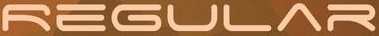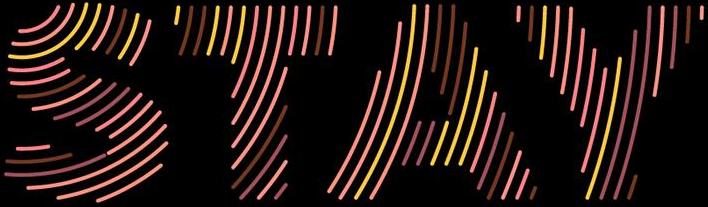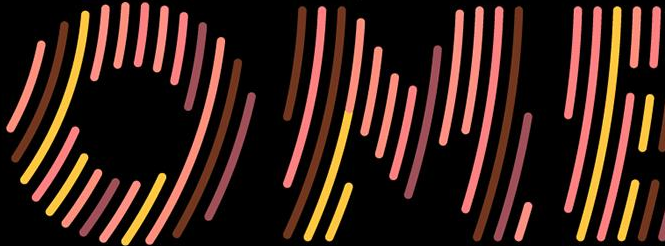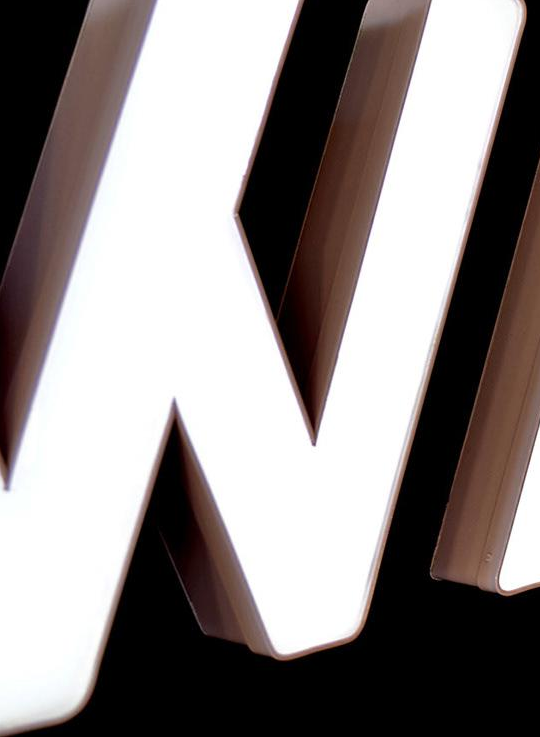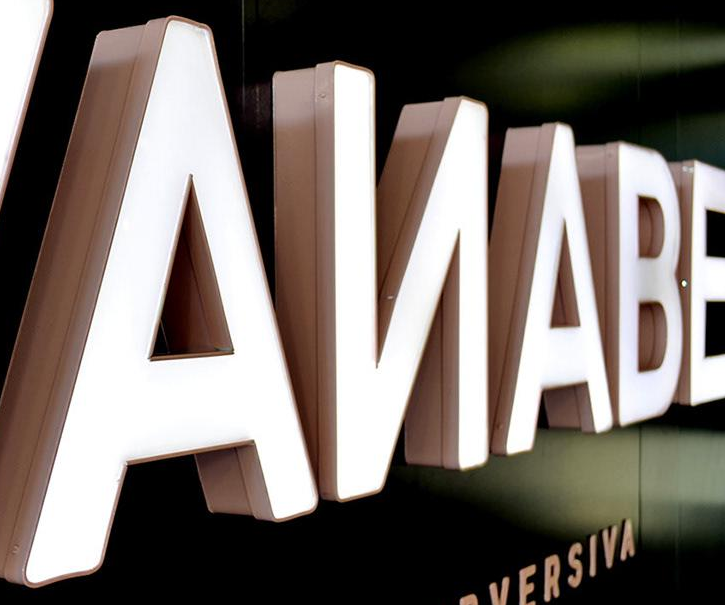What words can you see in these images in sequence, separated by a semicolon? REGULAR; STAY; OME; #; AИABE 